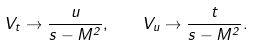<formula> <loc_0><loc_0><loc_500><loc_500>V _ { t } \to \frac { u } { s - M ^ { 2 } } , \quad V _ { u } \to \frac { t } { s - M ^ { 2 } } .</formula> 